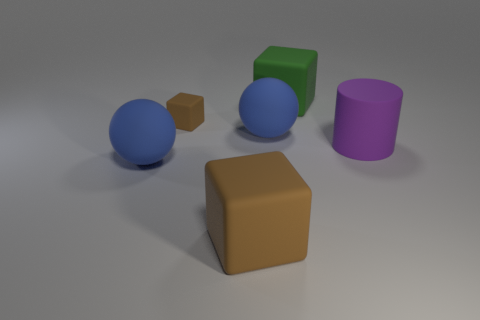Is the color of the ball that is to the right of the tiny matte block the same as the large matte ball in front of the large purple rubber object?
Your response must be concise. Yes. What number of yellow things are either rubber cubes or tiny matte cubes?
Make the answer very short. 0. How many purple cylinders have the same size as the green rubber object?
Your answer should be compact. 1. There is a blue rubber thing behind the large cylinder; are there any blue spheres to the right of it?
Give a very brief answer. No. Is the number of things behind the big brown block greater than the number of large purple matte objects that are right of the tiny brown matte thing?
Offer a very short reply. Yes. There is a tiny brown object that is the same material as the large green block; what shape is it?
Your answer should be compact. Cube. Is the number of blue rubber objects behind the large purple rubber object greater than the number of big blue cylinders?
Ensure brevity in your answer.  Yes. What number of balls are the same color as the small matte thing?
Your answer should be very brief. 0. What number of other objects are the same color as the big matte cylinder?
Make the answer very short. 0. Is the number of big green matte objects greater than the number of big gray matte spheres?
Offer a very short reply. Yes. 